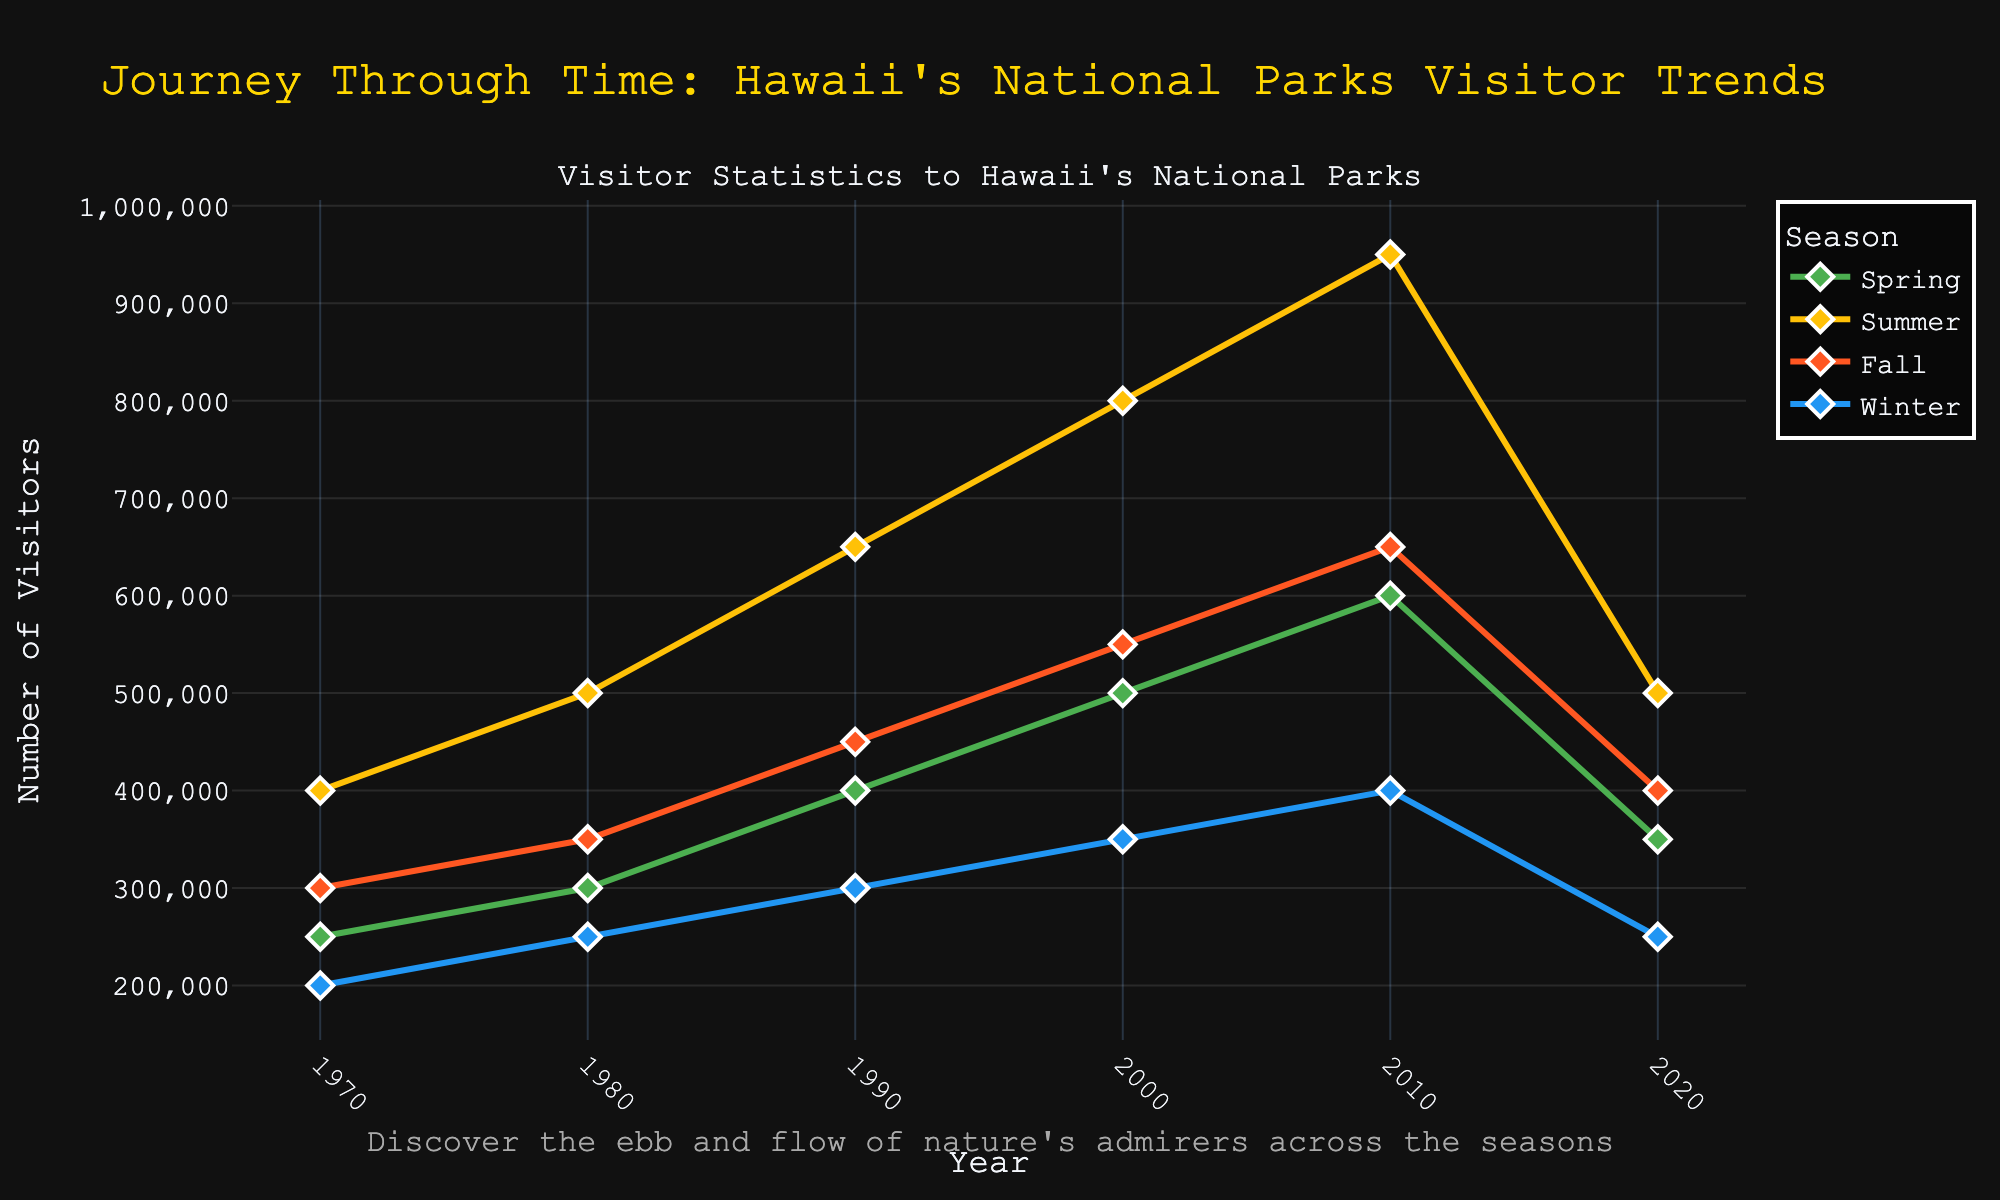What is the overall trend of visitor numbers to Hawaii's national parks from 1970 to 2020? The line chart shows an upward trend in visitor numbers from 1970 to 2010, with a significant increase during this period. However, from 2010 to 2020, there is a noticeable decline in visitor numbers for all seasons.
Answer: Upward from 1970 to 2010, then downward from 2010 to 2020 Which season had the highest number of visitors in 2020? By looking at the 2020 data points, the line for Summer is the highest among the seasons. Specifically, Summer had the most visitors in 2020.
Answer: Summer Compare the number of visitors in Winter 2000 to Winter 2010. Which year had more visitors and by how much? The line for Winter shows that there were 350,000 visitors in 2000 and 400,000 visitors in 2010. Thus, 2010 had more visitors by 50,000.
Answer: 2010 by 50,000 Which season had the most considerable increase in visitor numbers between 1990 and 2000? Comparing the 1990 and 2000 data points, all lines, the Summer season shows the largest increase from 650,000 in 1990 to 800,000 in 2000. The increase is 150,000, the largest among all seasons.
Answer: Summer In which year did the Spring season have the highest number of visitors? By examining the Spring line, its peak is in 2010, where it reaches 600,000 visitors. This is the highest value for the Spring season on the chart.
Answer: 2010 Between 1980 and 1990, how did Fall visitor numbers change? By looking at the Fall line, visitors in 1980 were 350,000, while in 1990, the number increased to 450,000. This indicates an increase of 100,000 visitors over this period.
Answer: Increased by 100,000 Compute the average number of visitors for the Summer season over the 50-year period. To find the average, sum the number of visitors in the Summer season for all years provided (400,000 + 500,000 + 650,000 + 800,000 + 950,000 + 500,000) and divide by the number of years (6). The total is 3,800,000. Thus, the average is 3,800,000 / 6 ≈ 633,333.
Answer: 633,333 What is the most significant drop in visitor numbers among all seasons between two consecutive decades? To determine the biggest drop, compare the visitor numbers in each season between consecutive decades. The largest drop is in Spring from 2010 (600,000) to 2020 (350,000), a decrease of 250,000 visitors.
Answer: Spring with a drop of 250,000 How did visitor numbers in Fall 2020 compare to Fall 1970? Were there more or less visitors in 2020 and by what percentage? Fall visitors in 1970 were 300,000, and in 2020, it was 400,000. This is an increase of 100,000 visitors. The percentage increase is (100,000 / 300,000) * 100% = 33.33%.
Answer: 33.33% increase What is the total number of visitors for all seasons combined in the year 2000? To find the total, sum the number of visitors for all seasons in the year 2000: 500,000 (Spring) + 800,000 (Summer) + 550,000 (Fall) + 350,000 (Winter) = 2,200,000.
Answer: 2,200,000 